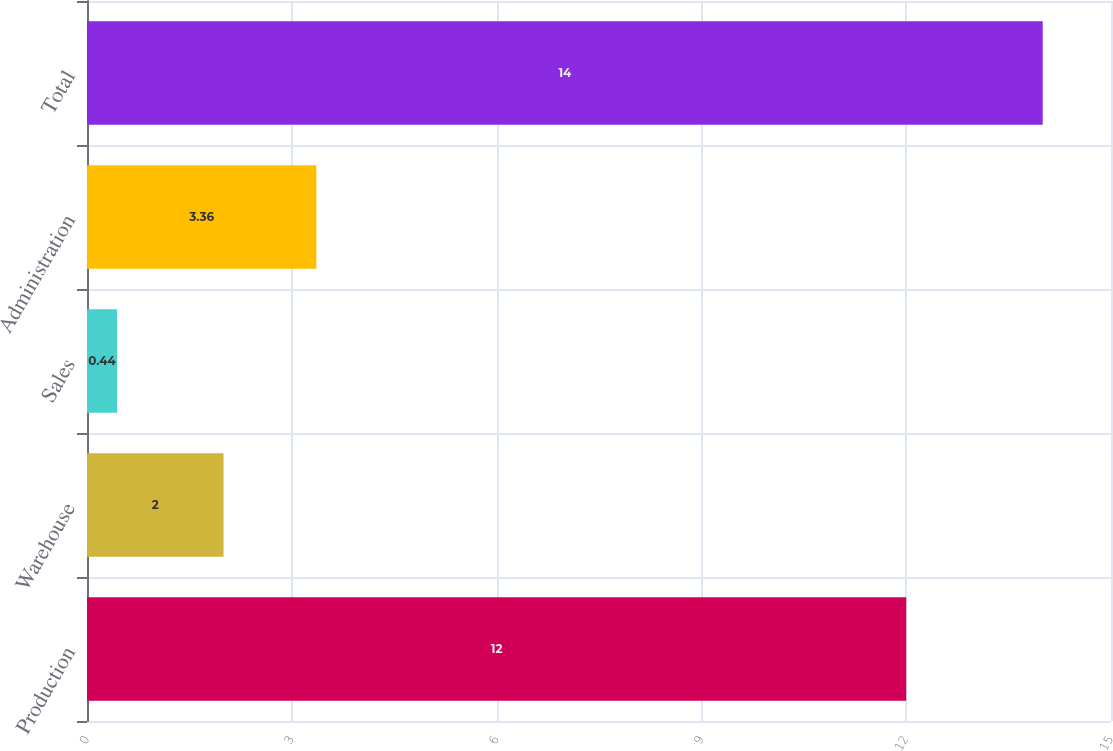Convert chart to OTSL. <chart><loc_0><loc_0><loc_500><loc_500><bar_chart><fcel>Production<fcel>Warehouse<fcel>Sales<fcel>Administration<fcel>Total<nl><fcel>12<fcel>2<fcel>0.44<fcel>3.36<fcel>14<nl></chart> 